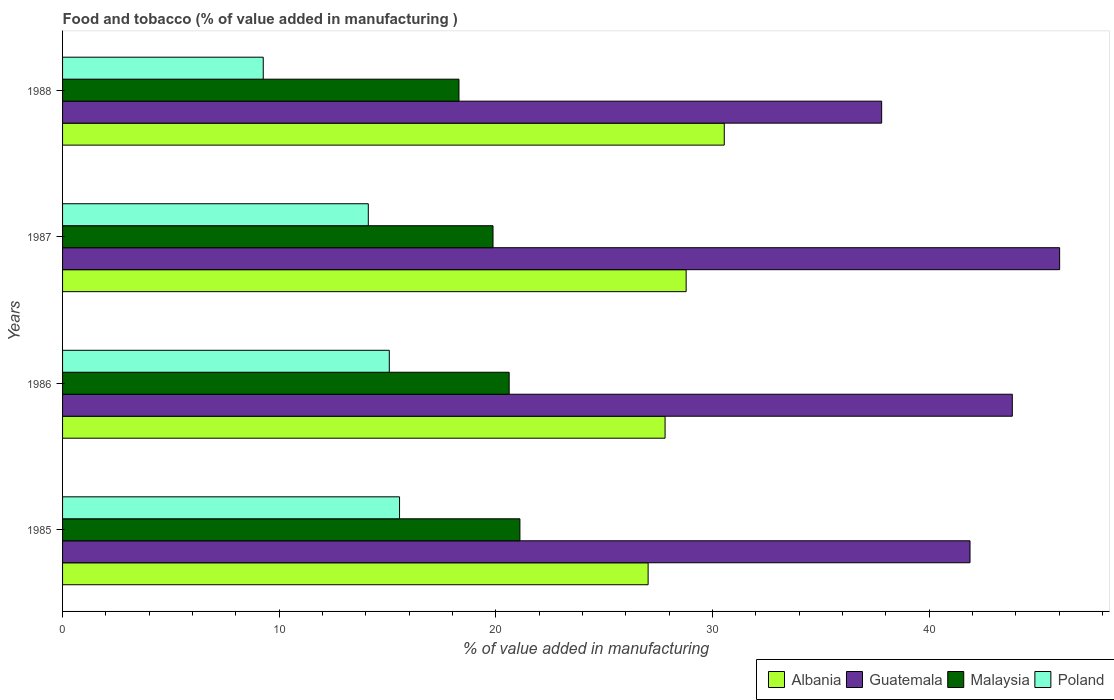How many different coloured bars are there?
Make the answer very short. 4. What is the value added in manufacturing food and tobacco in Poland in 1985?
Your answer should be compact. 15.56. Across all years, what is the maximum value added in manufacturing food and tobacco in Guatemala?
Keep it short and to the point. 46.03. Across all years, what is the minimum value added in manufacturing food and tobacco in Albania?
Give a very brief answer. 27.03. In which year was the value added in manufacturing food and tobacco in Guatemala maximum?
Make the answer very short. 1987. In which year was the value added in manufacturing food and tobacco in Poland minimum?
Ensure brevity in your answer.  1988. What is the total value added in manufacturing food and tobacco in Guatemala in the graph?
Make the answer very short. 169.57. What is the difference between the value added in manufacturing food and tobacco in Guatemala in 1985 and that in 1988?
Your answer should be compact. 4.08. What is the difference between the value added in manufacturing food and tobacco in Poland in 1988 and the value added in manufacturing food and tobacco in Malaysia in 1986?
Keep it short and to the point. -11.35. What is the average value added in manufacturing food and tobacco in Malaysia per year?
Give a very brief answer. 19.97. In the year 1986, what is the difference between the value added in manufacturing food and tobacco in Malaysia and value added in manufacturing food and tobacco in Albania?
Offer a very short reply. -7.2. In how many years, is the value added in manufacturing food and tobacco in Albania greater than 42 %?
Your answer should be very brief. 0. What is the ratio of the value added in manufacturing food and tobacco in Poland in 1987 to that in 1988?
Give a very brief answer. 1.52. What is the difference between the highest and the second highest value added in manufacturing food and tobacco in Albania?
Keep it short and to the point. 1.76. What is the difference between the highest and the lowest value added in manufacturing food and tobacco in Guatemala?
Offer a very short reply. 8.22. Is the sum of the value added in manufacturing food and tobacco in Poland in 1985 and 1988 greater than the maximum value added in manufacturing food and tobacco in Guatemala across all years?
Give a very brief answer. No. What does the 4th bar from the bottom in 1986 represents?
Ensure brevity in your answer.  Poland. Is it the case that in every year, the sum of the value added in manufacturing food and tobacco in Albania and value added in manufacturing food and tobacco in Guatemala is greater than the value added in manufacturing food and tobacco in Malaysia?
Offer a terse response. Yes. How many bars are there?
Offer a very short reply. 16. What is the difference between two consecutive major ticks on the X-axis?
Your answer should be compact. 10. Are the values on the major ticks of X-axis written in scientific E-notation?
Your answer should be very brief. No. How many legend labels are there?
Your response must be concise. 4. What is the title of the graph?
Your answer should be very brief. Food and tobacco (% of value added in manufacturing ). Does "Bhutan" appear as one of the legend labels in the graph?
Make the answer very short. No. What is the label or title of the X-axis?
Your answer should be compact. % of value added in manufacturing. What is the % of value added in manufacturing of Albania in 1985?
Make the answer very short. 27.03. What is the % of value added in manufacturing of Guatemala in 1985?
Ensure brevity in your answer.  41.89. What is the % of value added in manufacturing in Malaysia in 1985?
Provide a short and direct response. 21.11. What is the % of value added in manufacturing in Poland in 1985?
Your answer should be compact. 15.56. What is the % of value added in manufacturing in Albania in 1986?
Your answer should be very brief. 27.81. What is the % of value added in manufacturing of Guatemala in 1986?
Offer a terse response. 43.84. What is the % of value added in manufacturing of Malaysia in 1986?
Your response must be concise. 20.62. What is the % of value added in manufacturing in Poland in 1986?
Your answer should be compact. 15.08. What is the % of value added in manufacturing of Albania in 1987?
Keep it short and to the point. 28.79. What is the % of value added in manufacturing in Guatemala in 1987?
Your response must be concise. 46.03. What is the % of value added in manufacturing of Malaysia in 1987?
Your answer should be compact. 19.87. What is the % of value added in manufacturing of Poland in 1987?
Your response must be concise. 14.11. What is the % of value added in manufacturing of Albania in 1988?
Ensure brevity in your answer.  30.55. What is the % of value added in manufacturing in Guatemala in 1988?
Make the answer very short. 37.81. What is the % of value added in manufacturing in Malaysia in 1988?
Make the answer very short. 18.3. What is the % of value added in manufacturing of Poland in 1988?
Provide a succinct answer. 9.26. Across all years, what is the maximum % of value added in manufacturing in Albania?
Give a very brief answer. 30.55. Across all years, what is the maximum % of value added in manufacturing of Guatemala?
Give a very brief answer. 46.03. Across all years, what is the maximum % of value added in manufacturing in Malaysia?
Provide a succinct answer. 21.11. Across all years, what is the maximum % of value added in manufacturing in Poland?
Ensure brevity in your answer.  15.56. Across all years, what is the minimum % of value added in manufacturing of Albania?
Provide a short and direct response. 27.03. Across all years, what is the minimum % of value added in manufacturing of Guatemala?
Provide a short and direct response. 37.81. Across all years, what is the minimum % of value added in manufacturing in Malaysia?
Make the answer very short. 18.3. Across all years, what is the minimum % of value added in manufacturing in Poland?
Provide a succinct answer. 9.26. What is the total % of value added in manufacturing of Albania in the graph?
Ensure brevity in your answer.  114.17. What is the total % of value added in manufacturing of Guatemala in the graph?
Ensure brevity in your answer.  169.57. What is the total % of value added in manufacturing of Malaysia in the graph?
Keep it short and to the point. 79.9. What is the total % of value added in manufacturing in Poland in the graph?
Your response must be concise. 54.01. What is the difference between the % of value added in manufacturing in Albania in 1985 and that in 1986?
Your response must be concise. -0.78. What is the difference between the % of value added in manufacturing of Guatemala in 1985 and that in 1986?
Make the answer very short. -1.95. What is the difference between the % of value added in manufacturing in Malaysia in 1985 and that in 1986?
Offer a very short reply. 0.5. What is the difference between the % of value added in manufacturing in Poland in 1985 and that in 1986?
Your answer should be very brief. 0.47. What is the difference between the % of value added in manufacturing of Albania in 1985 and that in 1987?
Offer a very short reply. -1.76. What is the difference between the % of value added in manufacturing of Guatemala in 1985 and that in 1987?
Provide a short and direct response. -4.14. What is the difference between the % of value added in manufacturing of Malaysia in 1985 and that in 1987?
Provide a short and direct response. 1.24. What is the difference between the % of value added in manufacturing in Poland in 1985 and that in 1987?
Offer a very short reply. 1.44. What is the difference between the % of value added in manufacturing of Albania in 1985 and that in 1988?
Make the answer very short. -3.51. What is the difference between the % of value added in manufacturing of Guatemala in 1985 and that in 1988?
Your answer should be compact. 4.08. What is the difference between the % of value added in manufacturing in Malaysia in 1985 and that in 1988?
Offer a terse response. 2.81. What is the difference between the % of value added in manufacturing in Poland in 1985 and that in 1988?
Give a very brief answer. 6.29. What is the difference between the % of value added in manufacturing in Albania in 1986 and that in 1987?
Your answer should be compact. -0.97. What is the difference between the % of value added in manufacturing of Guatemala in 1986 and that in 1987?
Your answer should be compact. -2.18. What is the difference between the % of value added in manufacturing in Malaysia in 1986 and that in 1987?
Keep it short and to the point. 0.75. What is the difference between the % of value added in manufacturing of Poland in 1986 and that in 1987?
Provide a short and direct response. 0.97. What is the difference between the % of value added in manufacturing of Albania in 1986 and that in 1988?
Your response must be concise. -2.73. What is the difference between the % of value added in manufacturing of Guatemala in 1986 and that in 1988?
Make the answer very short. 6.03. What is the difference between the % of value added in manufacturing of Malaysia in 1986 and that in 1988?
Provide a succinct answer. 2.32. What is the difference between the % of value added in manufacturing of Poland in 1986 and that in 1988?
Provide a short and direct response. 5.82. What is the difference between the % of value added in manufacturing in Albania in 1987 and that in 1988?
Offer a very short reply. -1.76. What is the difference between the % of value added in manufacturing in Guatemala in 1987 and that in 1988?
Make the answer very short. 8.22. What is the difference between the % of value added in manufacturing in Malaysia in 1987 and that in 1988?
Provide a succinct answer. 1.57. What is the difference between the % of value added in manufacturing in Poland in 1987 and that in 1988?
Your answer should be compact. 4.85. What is the difference between the % of value added in manufacturing in Albania in 1985 and the % of value added in manufacturing in Guatemala in 1986?
Ensure brevity in your answer.  -16.81. What is the difference between the % of value added in manufacturing of Albania in 1985 and the % of value added in manufacturing of Malaysia in 1986?
Your response must be concise. 6.42. What is the difference between the % of value added in manufacturing in Albania in 1985 and the % of value added in manufacturing in Poland in 1986?
Your answer should be compact. 11.95. What is the difference between the % of value added in manufacturing in Guatemala in 1985 and the % of value added in manufacturing in Malaysia in 1986?
Offer a very short reply. 21.27. What is the difference between the % of value added in manufacturing of Guatemala in 1985 and the % of value added in manufacturing of Poland in 1986?
Provide a short and direct response. 26.81. What is the difference between the % of value added in manufacturing of Malaysia in 1985 and the % of value added in manufacturing of Poland in 1986?
Offer a very short reply. 6.03. What is the difference between the % of value added in manufacturing in Albania in 1985 and the % of value added in manufacturing in Guatemala in 1987?
Your response must be concise. -19. What is the difference between the % of value added in manufacturing in Albania in 1985 and the % of value added in manufacturing in Malaysia in 1987?
Make the answer very short. 7.16. What is the difference between the % of value added in manufacturing of Albania in 1985 and the % of value added in manufacturing of Poland in 1987?
Your answer should be very brief. 12.92. What is the difference between the % of value added in manufacturing of Guatemala in 1985 and the % of value added in manufacturing of Malaysia in 1987?
Keep it short and to the point. 22.02. What is the difference between the % of value added in manufacturing of Guatemala in 1985 and the % of value added in manufacturing of Poland in 1987?
Make the answer very short. 27.78. What is the difference between the % of value added in manufacturing in Malaysia in 1985 and the % of value added in manufacturing in Poland in 1987?
Your response must be concise. 7. What is the difference between the % of value added in manufacturing of Albania in 1985 and the % of value added in manufacturing of Guatemala in 1988?
Offer a very short reply. -10.78. What is the difference between the % of value added in manufacturing of Albania in 1985 and the % of value added in manufacturing of Malaysia in 1988?
Offer a terse response. 8.73. What is the difference between the % of value added in manufacturing of Albania in 1985 and the % of value added in manufacturing of Poland in 1988?
Your answer should be compact. 17.77. What is the difference between the % of value added in manufacturing of Guatemala in 1985 and the % of value added in manufacturing of Malaysia in 1988?
Provide a succinct answer. 23.59. What is the difference between the % of value added in manufacturing in Guatemala in 1985 and the % of value added in manufacturing in Poland in 1988?
Ensure brevity in your answer.  32.62. What is the difference between the % of value added in manufacturing of Malaysia in 1985 and the % of value added in manufacturing of Poland in 1988?
Offer a terse response. 11.85. What is the difference between the % of value added in manufacturing in Albania in 1986 and the % of value added in manufacturing in Guatemala in 1987?
Your response must be concise. -18.21. What is the difference between the % of value added in manufacturing of Albania in 1986 and the % of value added in manufacturing of Malaysia in 1987?
Give a very brief answer. 7.94. What is the difference between the % of value added in manufacturing of Albania in 1986 and the % of value added in manufacturing of Poland in 1987?
Make the answer very short. 13.7. What is the difference between the % of value added in manufacturing in Guatemala in 1986 and the % of value added in manufacturing in Malaysia in 1987?
Your answer should be compact. 23.97. What is the difference between the % of value added in manufacturing of Guatemala in 1986 and the % of value added in manufacturing of Poland in 1987?
Keep it short and to the point. 29.73. What is the difference between the % of value added in manufacturing in Malaysia in 1986 and the % of value added in manufacturing in Poland in 1987?
Your answer should be compact. 6.5. What is the difference between the % of value added in manufacturing of Albania in 1986 and the % of value added in manufacturing of Guatemala in 1988?
Give a very brief answer. -10. What is the difference between the % of value added in manufacturing in Albania in 1986 and the % of value added in manufacturing in Malaysia in 1988?
Give a very brief answer. 9.51. What is the difference between the % of value added in manufacturing of Albania in 1986 and the % of value added in manufacturing of Poland in 1988?
Provide a short and direct response. 18.55. What is the difference between the % of value added in manufacturing of Guatemala in 1986 and the % of value added in manufacturing of Malaysia in 1988?
Make the answer very short. 25.54. What is the difference between the % of value added in manufacturing in Guatemala in 1986 and the % of value added in manufacturing in Poland in 1988?
Keep it short and to the point. 34.58. What is the difference between the % of value added in manufacturing in Malaysia in 1986 and the % of value added in manufacturing in Poland in 1988?
Your answer should be compact. 11.35. What is the difference between the % of value added in manufacturing of Albania in 1987 and the % of value added in manufacturing of Guatemala in 1988?
Offer a very short reply. -9.03. What is the difference between the % of value added in manufacturing of Albania in 1987 and the % of value added in manufacturing of Malaysia in 1988?
Make the answer very short. 10.49. What is the difference between the % of value added in manufacturing of Albania in 1987 and the % of value added in manufacturing of Poland in 1988?
Your answer should be very brief. 19.52. What is the difference between the % of value added in manufacturing in Guatemala in 1987 and the % of value added in manufacturing in Malaysia in 1988?
Provide a short and direct response. 27.73. What is the difference between the % of value added in manufacturing in Guatemala in 1987 and the % of value added in manufacturing in Poland in 1988?
Offer a terse response. 36.76. What is the difference between the % of value added in manufacturing in Malaysia in 1987 and the % of value added in manufacturing in Poland in 1988?
Ensure brevity in your answer.  10.61. What is the average % of value added in manufacturing of Albania per year?
Offer a terse response. 28.54. What is the average % of value added in manufacturing in Guatemala per year?
Offer a terse response. 42.39. What is the average % of value added in manufacturing of Malaysia per year?
Give a very brief answer. 19.97. What is the average % of value added in manufacturing in Poland per year?
Your response must be concise. 13.5. In the year 1985, what is the difference between the % of value added in manufacturing of Albania and % of value added in manufacturing of Guatemala?
Offer a very short reply. -14.86. In the year 1985, what is the difference between the % of value added in manufacturing of Albania and % of value added in manufacturing of Malaysia?
Provide a short and direct response. 5.92. In the year 1985, what is the difference between the % of value added in manufacturing of Albania and % of value added in manufacturing of Poland?
Your response must be concise. 11.48. In the year 1985, what is the difference between the % of value added in manufacturing in Guatemala and % of value added in manufacturing in Malaysia?
Give a very brief answer. 20.78. In the year 1985, what is the difference between the % of value added in manufacturing in Guatemala and % of value added in manufacturing in Poland?
Your answer should be very brief. 26.33. In the year 1985, what is the difference between the % of value added in manufacturing in Malaysia and % of value added in manufacturing in Poland?
Keep it short and to the point. 5.56. In the year 1986, what is the difference between the % of value added in manufacturing of Albania and % of value added in manufacturing of Guatemala?
Provide a short and direct response. -16.03. In the year 1986, what is the difference between the % of value added in manufacturing in Albania and % of value added in manufacturing in Malaysia?
Your answer should be compact. 7.2. In the year 1986, what is the difference between the % of value added in manufacturing in Albania and % of value added in manufacturing in Poland?
Give a very brief answer. 12.73. In the year 1986, what is the difference between the % of value added in manufacturing of Guatemala and % of value added in manufacturing of Malaysia?
Make the answer very short. 23.23. In the year 1986, what is the difference between the % of value added in manufacturing in Guatemala and % of value added in manufacturing in Poland?
Your response must be concise. 28.76. In the year 1986, what is the difference between the % of value added in manufacturing in Malaysia and % of value added in manufacturing in Poland?
Your answer should be compact. 5.53. In the year 1987, what is the difference between the % of value added in manufacturing of Albania and % of value added in manufacturing of Guatemala?
Provide a succinct answer. -17.24. In the year 1987, what is the difference between the % of value added in manufacturing in Albania and % of value added in manufacturing in Malaysia?
Your answer should be very brief. 8.92. In the year 1987, what is the difference between the % of value added in manufacturing of Albania and % of value added in manufacturing of Poland?
Ensure brevity in your answer.  14.67. In the year 1987, what is the difference between the % of value added in manufacturing in Guatemala and % of value added in manufacturing in Malaysia?
Offer a very short reply. 26.16. In the year 1987, what is the difference between the % of value added in manufacturing of Guatemala and % of value added in manufacturing of Poland?
Ensure brevity in your answer.  31.91. In the year 1987, what is the difference between the % of value added in manufacturing in Malaysia and % of value added in manufacturing in Poland?
Offer a very short reply. 5.76. In the year 1988, what is the difference between the % of value added in manufacturing of Albania and % of value added in manufacturing of Guatemala?
Provide a succinct answer. -7.27. In the year 1988, what is the difference between the % of value added in manufacturing in Albania and % of value added in manufacturing in Malaysia?
Make the answer very short. 12.25. In the year 1988, what is the difference between the % of value added in manufacturing in Albania and % of value added in manufacturing in Poland?
Offer a very short reply. 21.28. In the year 1988, what is the difference between the % of value added in manufacturing of Guatemala and % of value added in manufacturing of Malaysia?
Keep it short and to the point. 19.51. In the year 1988, what is the difference between the % of value added in manufacturing in Guatemala and % of value added in manufacturing in Poland?
Make the answer very short. 28.55. In the year 1988, what is the difference between the % of value added in manufacturing of Malaysia and % of value added in manufacturing of Poland?
Offer a very short reply. 9.03. What is the ratio of the % of value added in manufacturing of Albania in 1985 to that in 1986?
Offer a very short reply. 0.97. What is the ratio of the % of value added in manufacturing of Guatemala in 1985 to that in 1986?
Keep it short and to the point. 0.96. What is the ratio of the % of value added in manufacturing in Malaysia in 1985 to that in 1986?
Provide a short and direct response. 1.02. What is the ratio of the % of value added in manufacturing in Poland in 1985 to that in 1986?
Your response must be concise. 1.03. What is the ratio of the % of value added in manufacturing in Albania in 1985 to that in 1987?
Offer a very short reply. 0.94. What is the ratio of the % of value added in manufacturing of Guatemala in 1985 to that in 1987?
Your response must be concise. 0.91. What is the ratio of the % of value added in manufacturing in Malaysia in 1985 to that in 1987?
Offer a very short reply. 1.06. What is the ratio of the % of value added in manufacturing of Poland in 1985 to that in 1987?
Offer a very short reply. 1.1. What is the ratio of the % of value added in manufacturing in Albania in 1985 to that in 1988?
Give a very brief answer. 0.88. What is the ratio of the % of value added in manufacturing of Guatemala in 1985 to that in 1988?
Provide a short and direct response. 1.11. What is the ratio of the % of value added in manufacturing of Malaysia in 1985 to that in 1988?
Your answer should be compact. 1.15. What is the ratio of the % of value added in manufacturing of Poland in 1985 to that in 1988?
Provide a short and direct response. 1.68. What is the ratio of the % of value added in manufacturing in Albania in 1986 to that in 1987?
Offer a very short reply. 0.97. What is the ratio of the % of value added in manufacturing of Guatemala in 1986 to that in 1987?
Your answer should be very brief. 0.95. What is the ratio of the % of value added in manufacturing of Malaysia in 1986 to that in 1987?
Offer a terse response. 1.04. What is the ratio of the % of value added in manufacturing of Poland in 1986 to that in 1987?
Give a very brief answer. 1.07. What is the ratio of the % of value added in manufacturing of Albania in 1986 to that in 1988?
Make the answer very short. 0.91. What is the ratio of the % of value added in manufacturing of Guatemala in 1986 to that in 1988?
Keep it short and to the point. 1.16. What is the ratio of the % of value added in manufacturing of Malaysia in 1986 to that in 1988?
Provide a short and direct response. 1.13. What is the ratio of the % of value added in manufacturing in Poland in 1986 to that in 1988?
Provide a short and direct response. 1.63. What is the ratio of the % of value added in manufacturing in Albania in 1987 to that in 1988?
Your answer should be compact. 0.94. What is the ratio of the % of value added in manufacturing of Guatemala in 1987 to that in 1988?
Offer a very short reply. 1.22. What is the ratio of the % of value added in manufacturing of Malaysia in 1987 to that in 1988?
Provide a short and direct response. 1.09. What is the ratio of the % of value added in manufacturing of Poland in 1987 to that in 1988?
Your answer should be very brief. 1.52. What is the difference between the highest and the second highest % of value added in manufacturing of Albania?
Your response must be concise. 1.76. What is the difference between the highest and the second highest % of value added in manufacturing in Guatemala?
Offer a terse response. 2.18. What is the difference between the highest and the second highest % of value added in manufacturing of Malaysia?
Your answer should be compact. 0.5. What is the difference between the highest and the second highest % of value added in manufacturing in Poland?
Offer a terse response. 0.47. What is the difference between the highest and the lowest % of value added in manufacturing of Albania?
Your answer should be compact. 3.51. What is the difference between the highest and the lowest % of value added in manufacturing of Guatemala?
Offer a terse response. 8.22. What is the difference between the highest and the lowest % of value added in manufacturing of Malaysia?
Make the answer very short. 2.81. What is the difference between the highest and the lowest % of value added in manufacturing in Poland?
Provide a succinct answer. 6.29. 